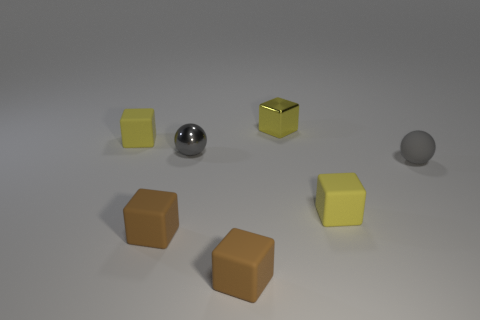Subtract all yellow cubes. How many were subtracted if there are2yellow cubes left? 1 Subtract all brown cylinders. How many yellow cubes are left? 3 Subtract 1 cubes. How many cubes are left? 4 Subtract all shiny cubes. How many cubes are left? 4 Subtract all purple cubes. Subtract all purple spheres. How many cubes are left? 5 Add 2 tiny yellow blocks. How many objects exist? 9 Subtract all spheres. How many objects are left? 5 Subtract 0 green cubes. How many objects are left? 7 Subtract all rubber cubes. Subtract all metallic objects. How many objects are left? 1 Add 1 gray things. How many gray things are left? 3 